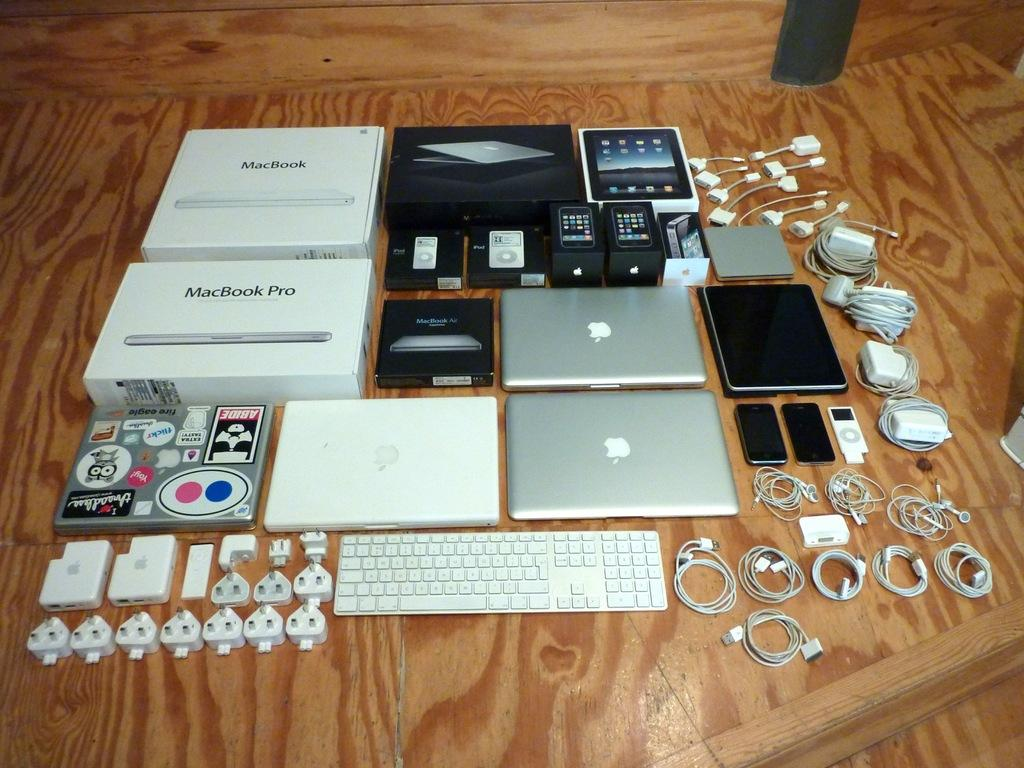Provide a one-sentence caption for the provided image. Some macbook pro boxes, laptops and accessories are spread out. 